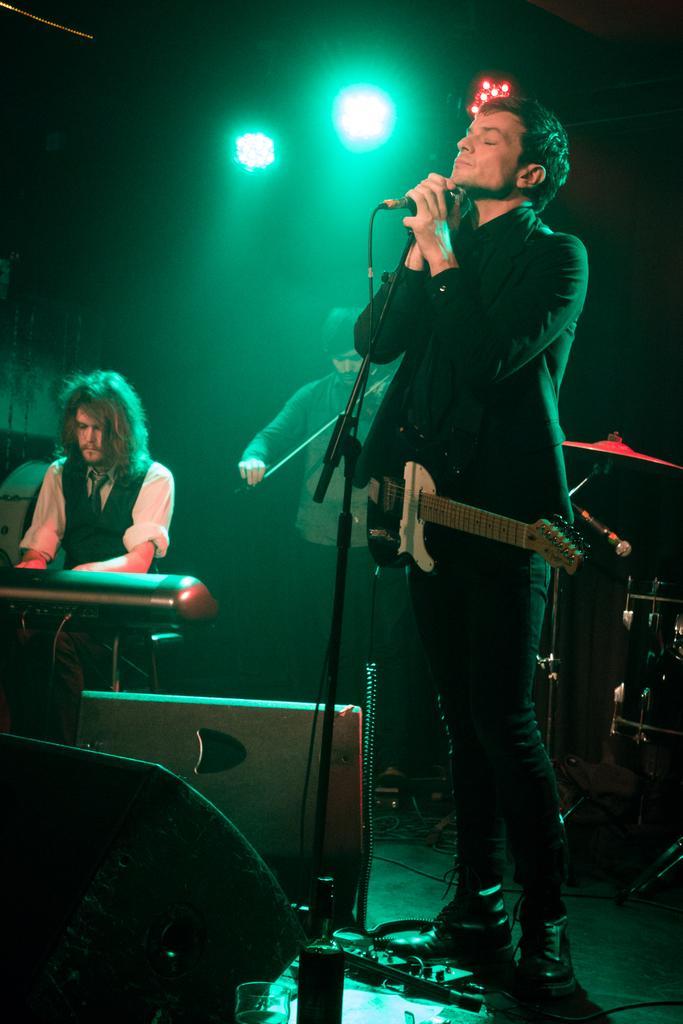Can you describe this image briefly? In this picture there is a boy who is standing at the right side of the image, by holding a mic in his hands and he is wearing a guitar over his suit, there is a speaker at the left side of the image and there are two people on the stage the one who is at the left side of the image, she is playing the piano, the person who is standing at the center of the image, he is playing the violin and there are spotlights around the area of the image and there is a drum set at the right side of the image. 